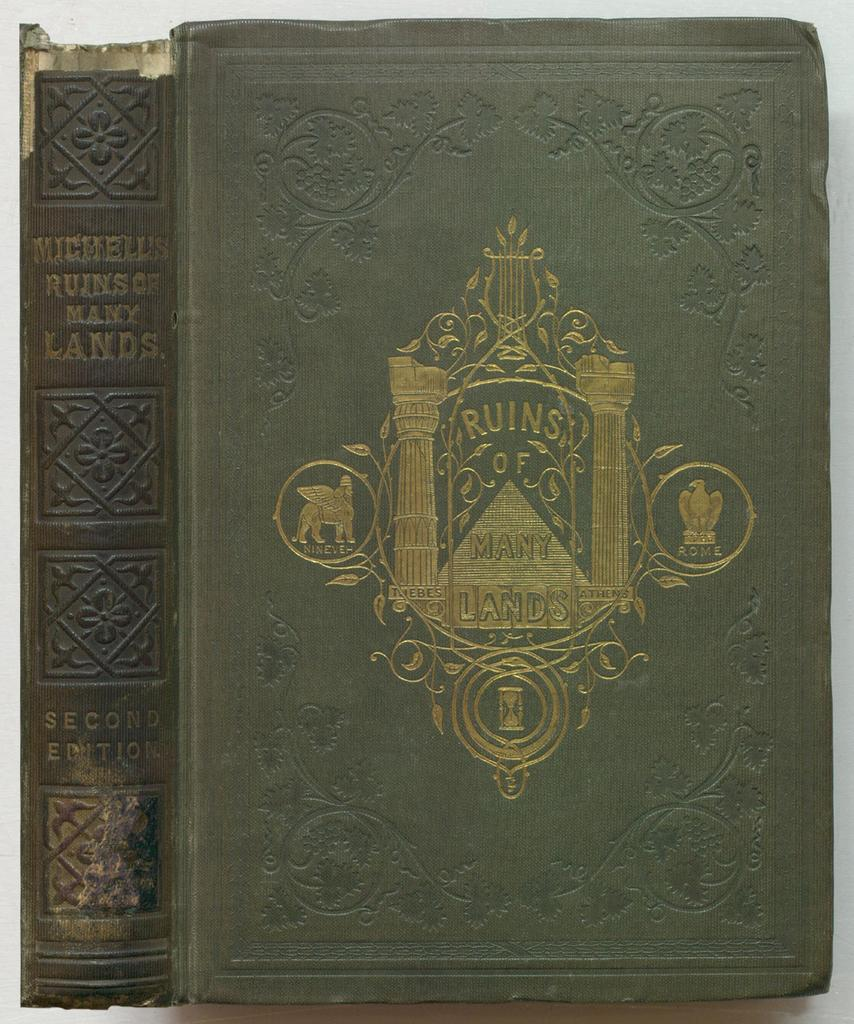<image>
Summarize the visual content of the image. The cover and spine of an old book entitled "Ruins of Many Lands". 